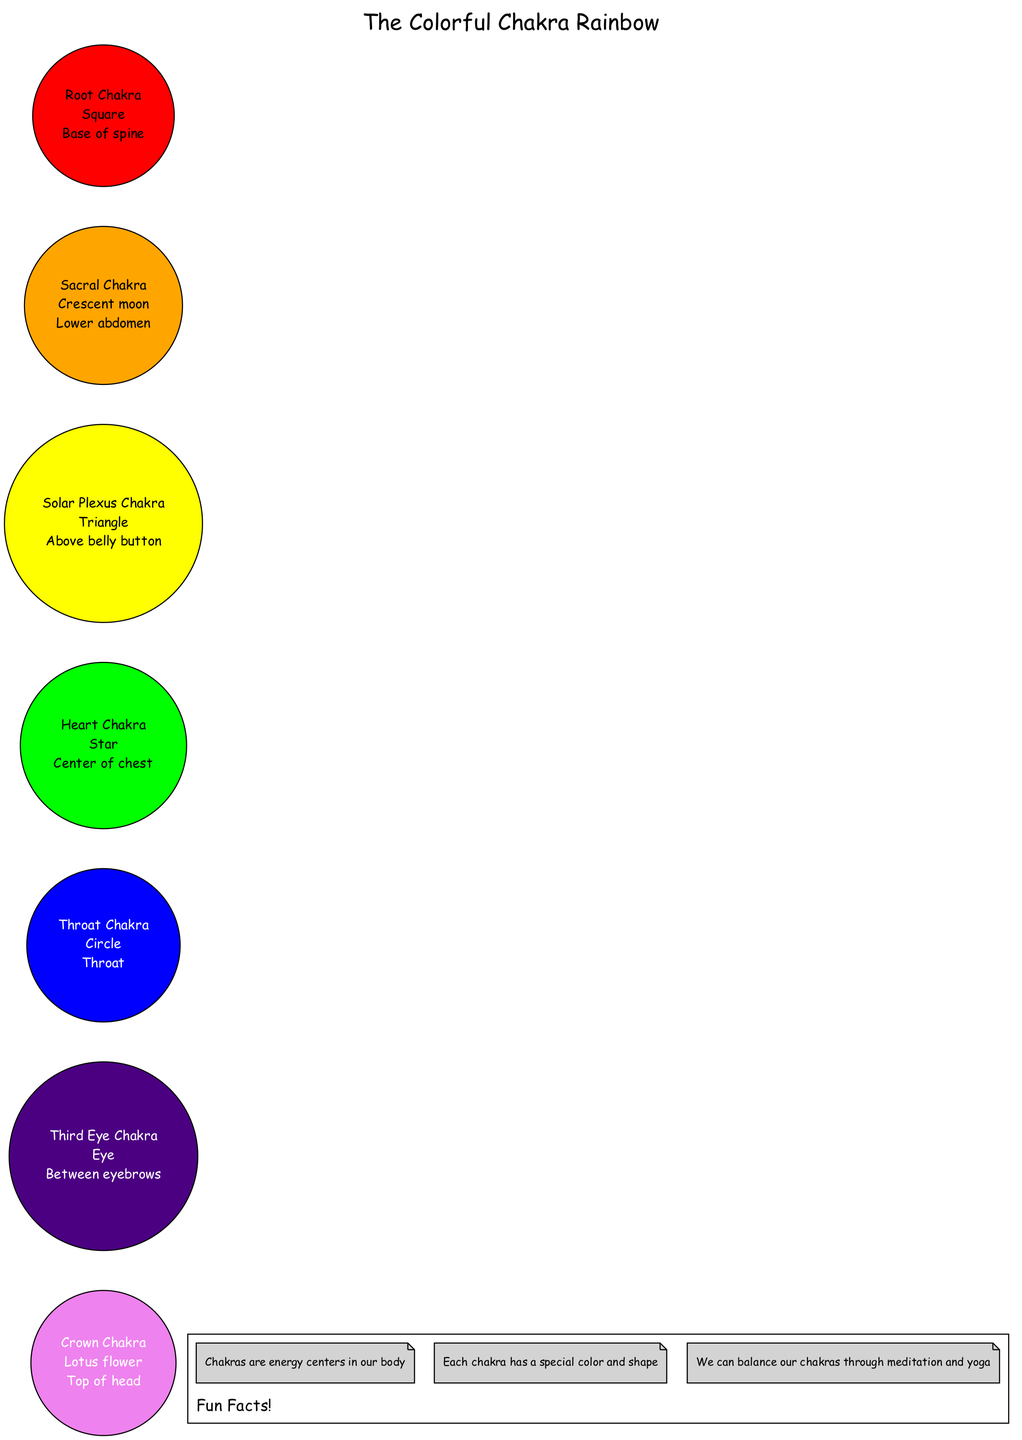What is the color of the Heart Chakra? The Heart Chakra is labeled as having the color "Green" in the diagram.
Answer: Green What is the symbol associated with the Root Chakra? The Root Chakra is represented by the symbol "Square" according to the diagram.
Answer: Square How many chakras are there in total? The diagram lists a total of seven chakras, as indicated by the number of elements in the diagram.
Answer: Seven Which chakra is located above the belly button? The Solar Plexus Chakra is positioned above the belly button, as stated in the location description for that chakra.
Answer: Solar Plexus Chakra What is the color of the Third Eye Chakra? The Third Eye Chakra is noted to be "Indigo" in the diagram.
Answer: Indigo How does the color of the Crown Chakra compare to the color of the Root Chakra? The Crown Chakra is "Violet" while the Root Chakra is "Red," showing a difference in the spectrum of colors where Violet is at the top (crown) and Red at the bottom (root).
Answer: Different colors Which chakra is associated with the lotus flower symbol? The Crown Chakra is associated with the "Lotus flower" symbol in the diagram.
Answer: Lotus flower Identify the chakra located at the base of the spine. The Root Chakra is identified as being located at the base of the spine in the diagram.
Answer: Root Chakra Which chakra is located between the eyebrows? The diagram specifies that the Third Eye Chakra is located between the eyebrows.
Answer: Third Eye Chakra 